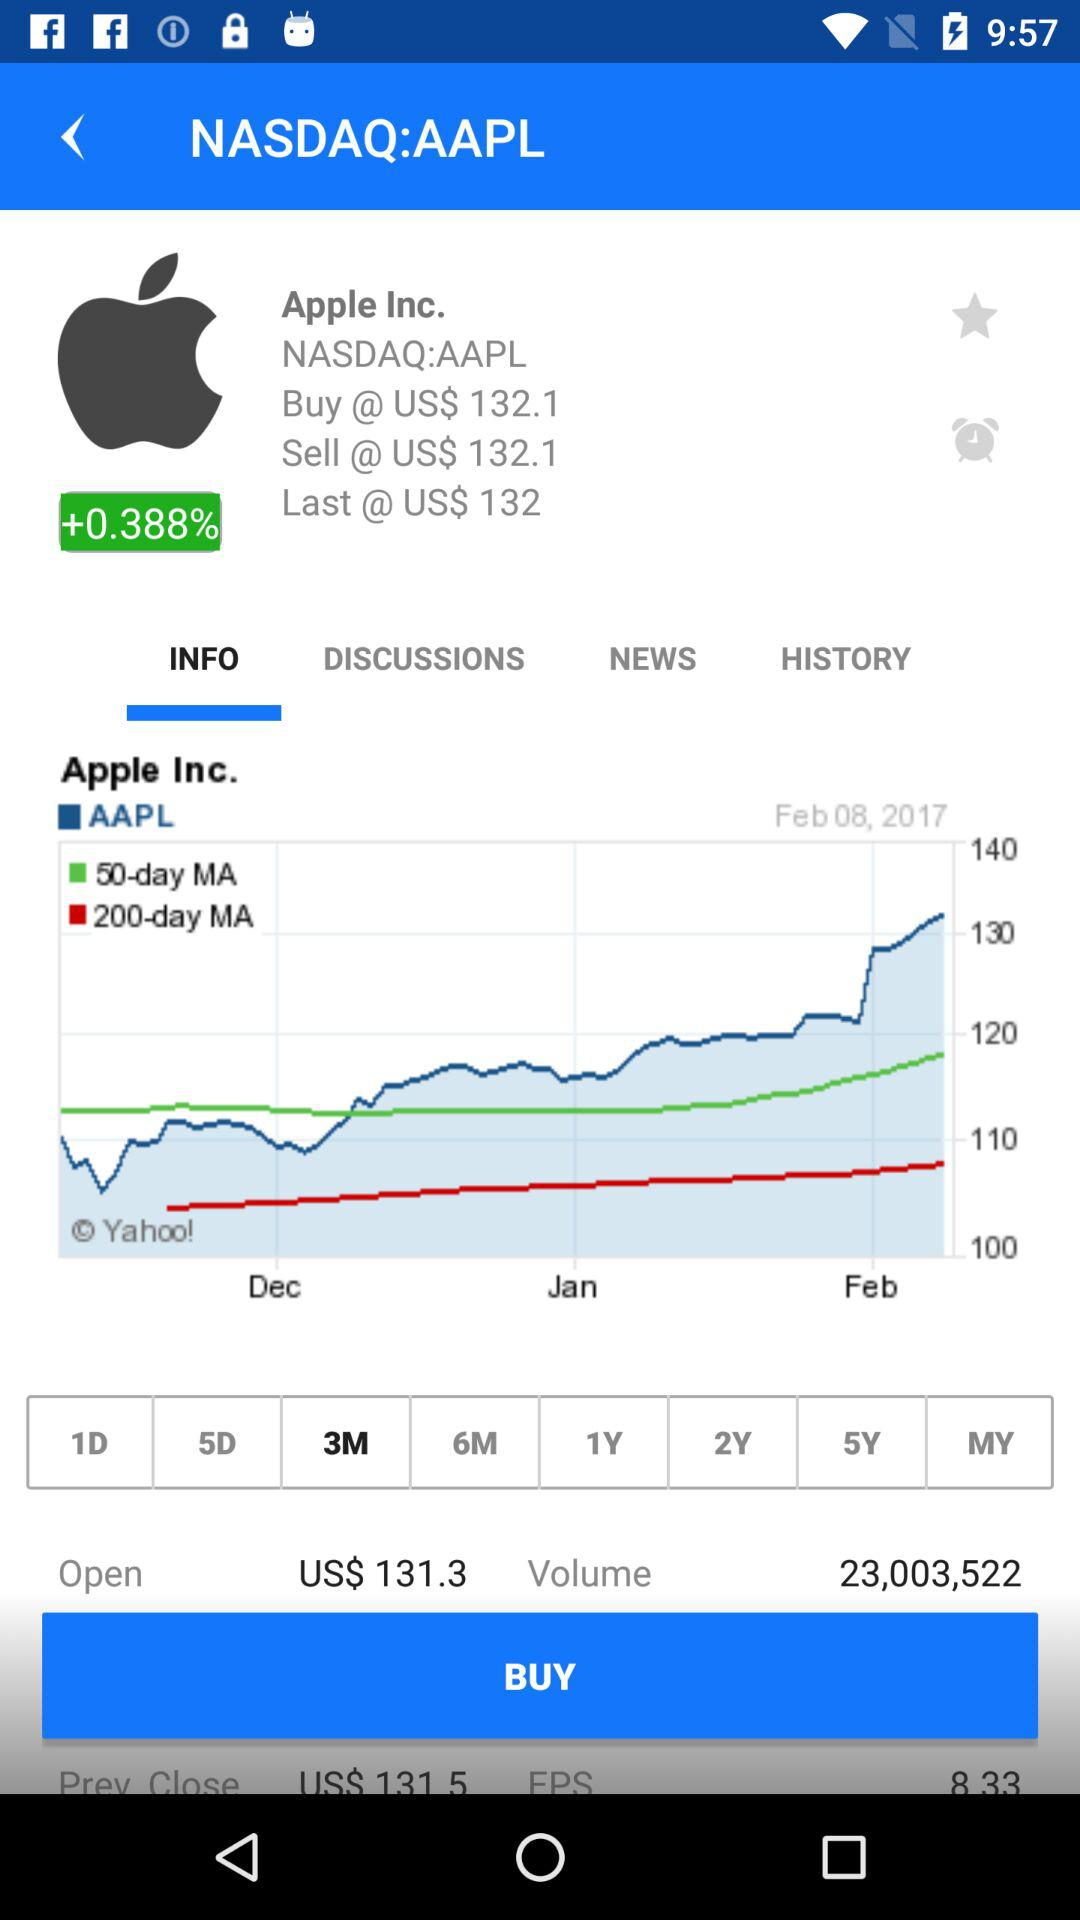Which month's data is shown in the bar graph? The months shown are December, January and February. 